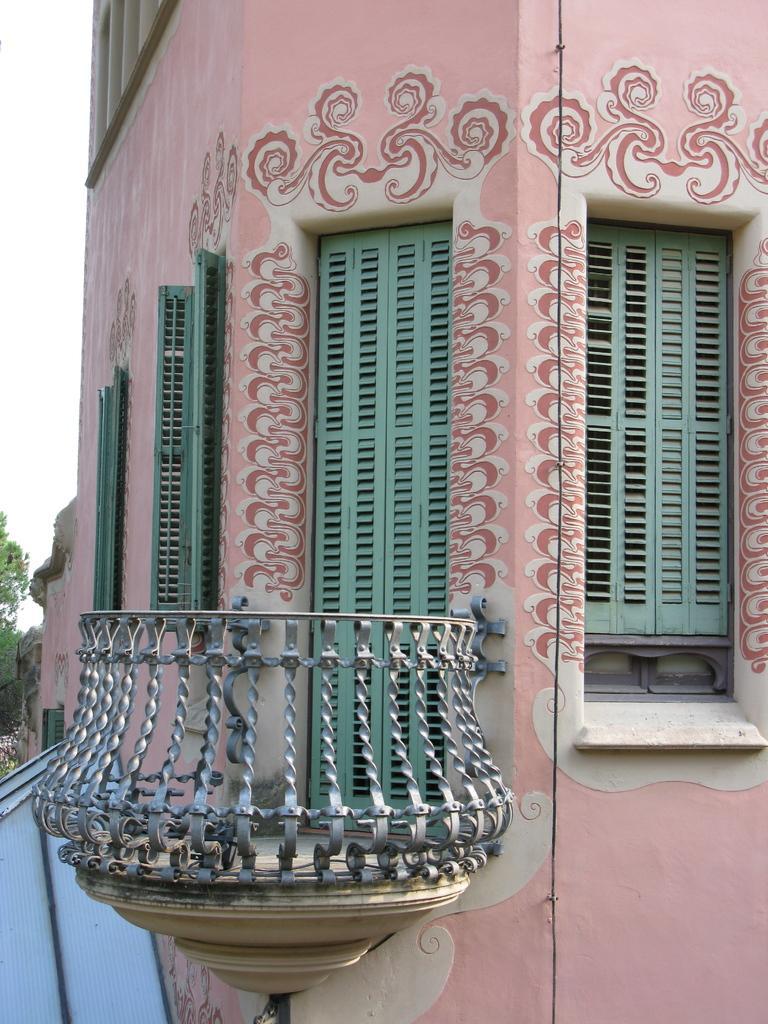How would you summarize this image in a sentence or two? In this picture we can see a building with windows, some objects and in the background we can see trees and the sky. 